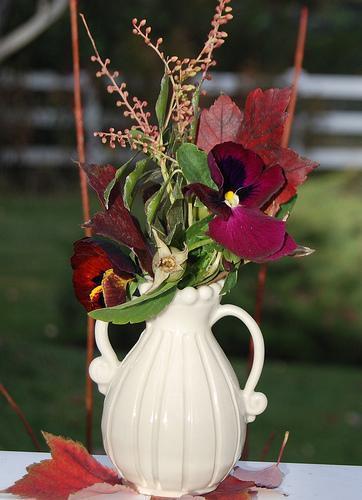How many vases are shown?
Give a very brief answer. 1. How many handles does the vase have?
Give a very brief answer. 2. How many slats high is the fence in the background?
Give a very brief answer. 3. How many purple flowers in the image?
Give a very brief answer. 2. 